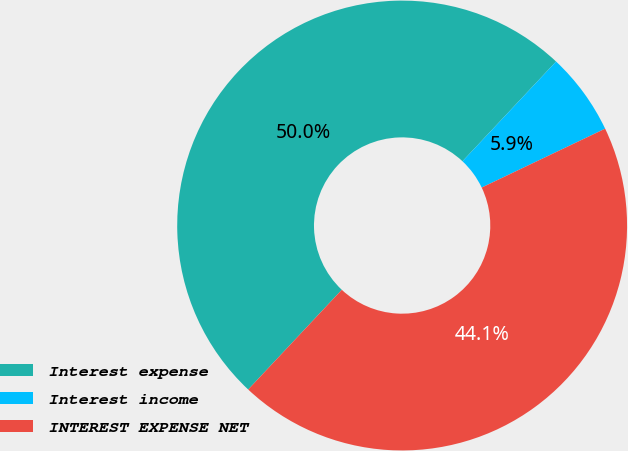Convert chart to OTSL. <chart><loc_0><loc_0><loc_500><loc_500><pie_chart><fcel>Interest expense<fcel>Interest income<fcel>INTEREST EXPENSE NET<nl><fcel>50.0%<fcel>5.92%<fcel>44.08%<nl></chart> 